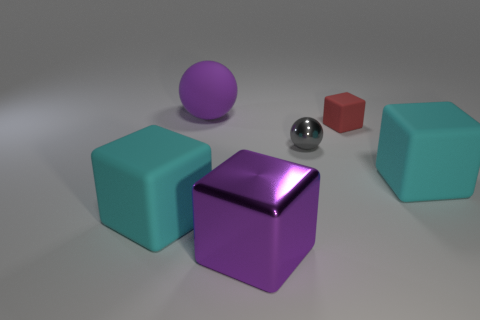Add 3 big gray rubber things. How many objects exist? 9 Subtract all balls. How many objects are left? 4 Add 5 gray rubber objects. How many gray rubber objects exist? 5 Subtract 0 brown blocks. How many objects are left? 6 Subtract all large cubes. Subtract all large cyan rubber things. How many objects are left? 1 Add 5 red rubber cubes. How many red rubber cubes are left? 6 